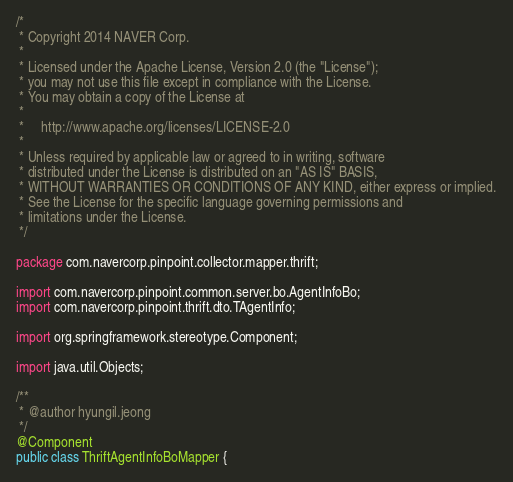Convert code to text. <code><loc_0><loc_0><loc_500><loc_500><_Java_>/*
 * Copyright 2014 NAVER Corp.
 *
 * Licensed under the Apache License, Version 2.0 (the "License");
 * you may not use this file except in compliance with the License.
 * You may obtain a copy of the License at
 *
 *     http://www.apache.org/licenses/LICENSE-2.0
 *
 * Unless required by applicable law or agreed to in writing, software
 * distributed under the License is distributed on an "AS IS" BASIS,
 * WITHOUT WARRANTIES OR CONDITIONS OF ANY KIND, either express or implied.
 * See the License for the specific language governing permissions and
 * limitations under the License.
 */

package com.navercorp.pinpoint.collector.mapper.thrift;

import com.navercorp.pinpoint.common.server.bo.AgentInfoBo;
import com.navercorp.pinpoint.thrift.dto.TAgentInfo;

import org.springframework.stereotype.Component;

import java.util.Objects;

/**
 * @author hyungil.jeong
 */
@Component
public class ThriftAgentInfoBoMapper {</code> 